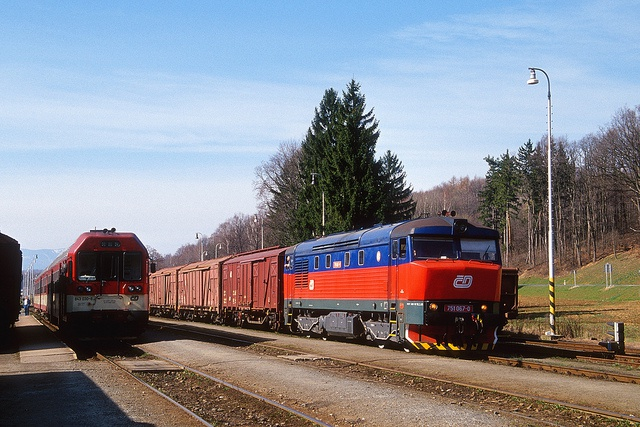Describe the objects in this image and their specific colors. I can see train in lightblue, black, maroon, gray, and brown tones, train in lightblue, black, maroon, gray, and brown tones, train in lightblue, black, darkgray, lightgray, and gray tones, and people in lightblue, black, navy, white, and gray tones in this image. 